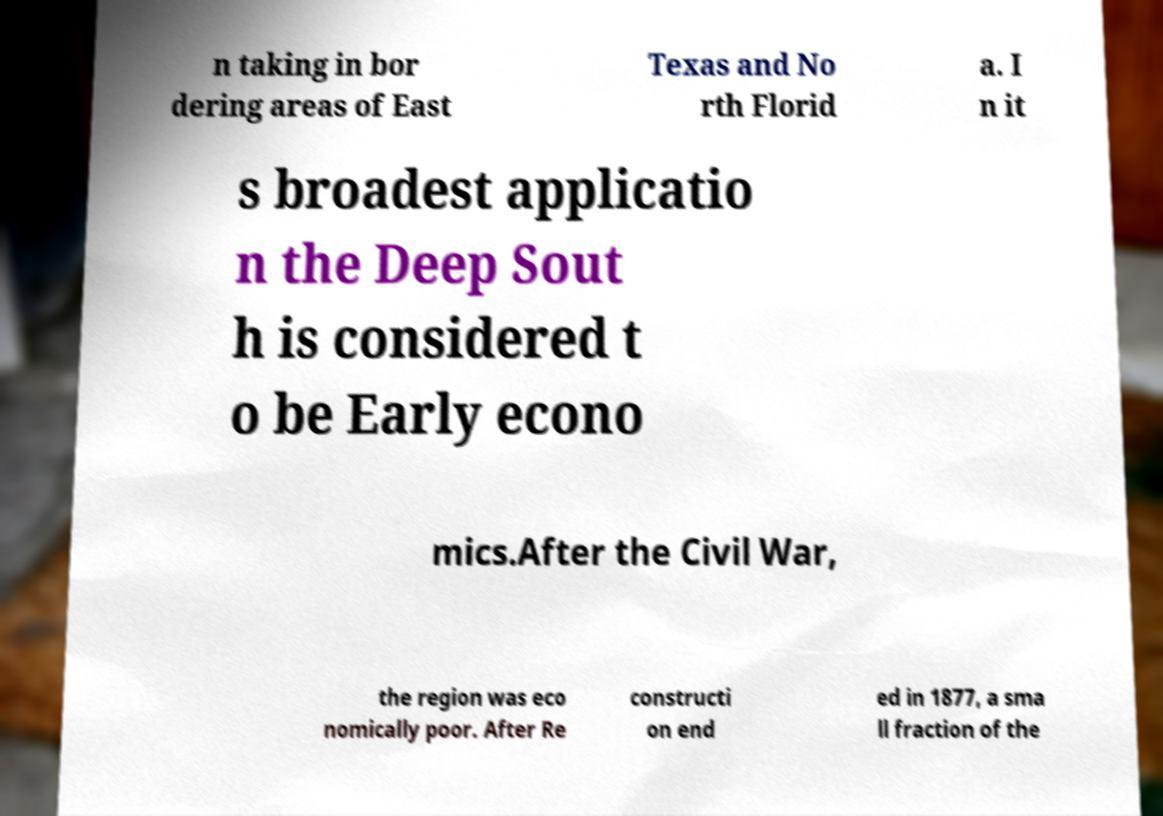Please read and relay the text visible in this image. What does it say? n taking in bor dering areas of East Texas and No rth Florid a. I n it s broadest applicatio n the Deep Sout h is considered t o be Early econo mics.After the Civil War, the region was eco nomically poor. After Re constructi on end ed in 1877, a sma ll fraction of the 